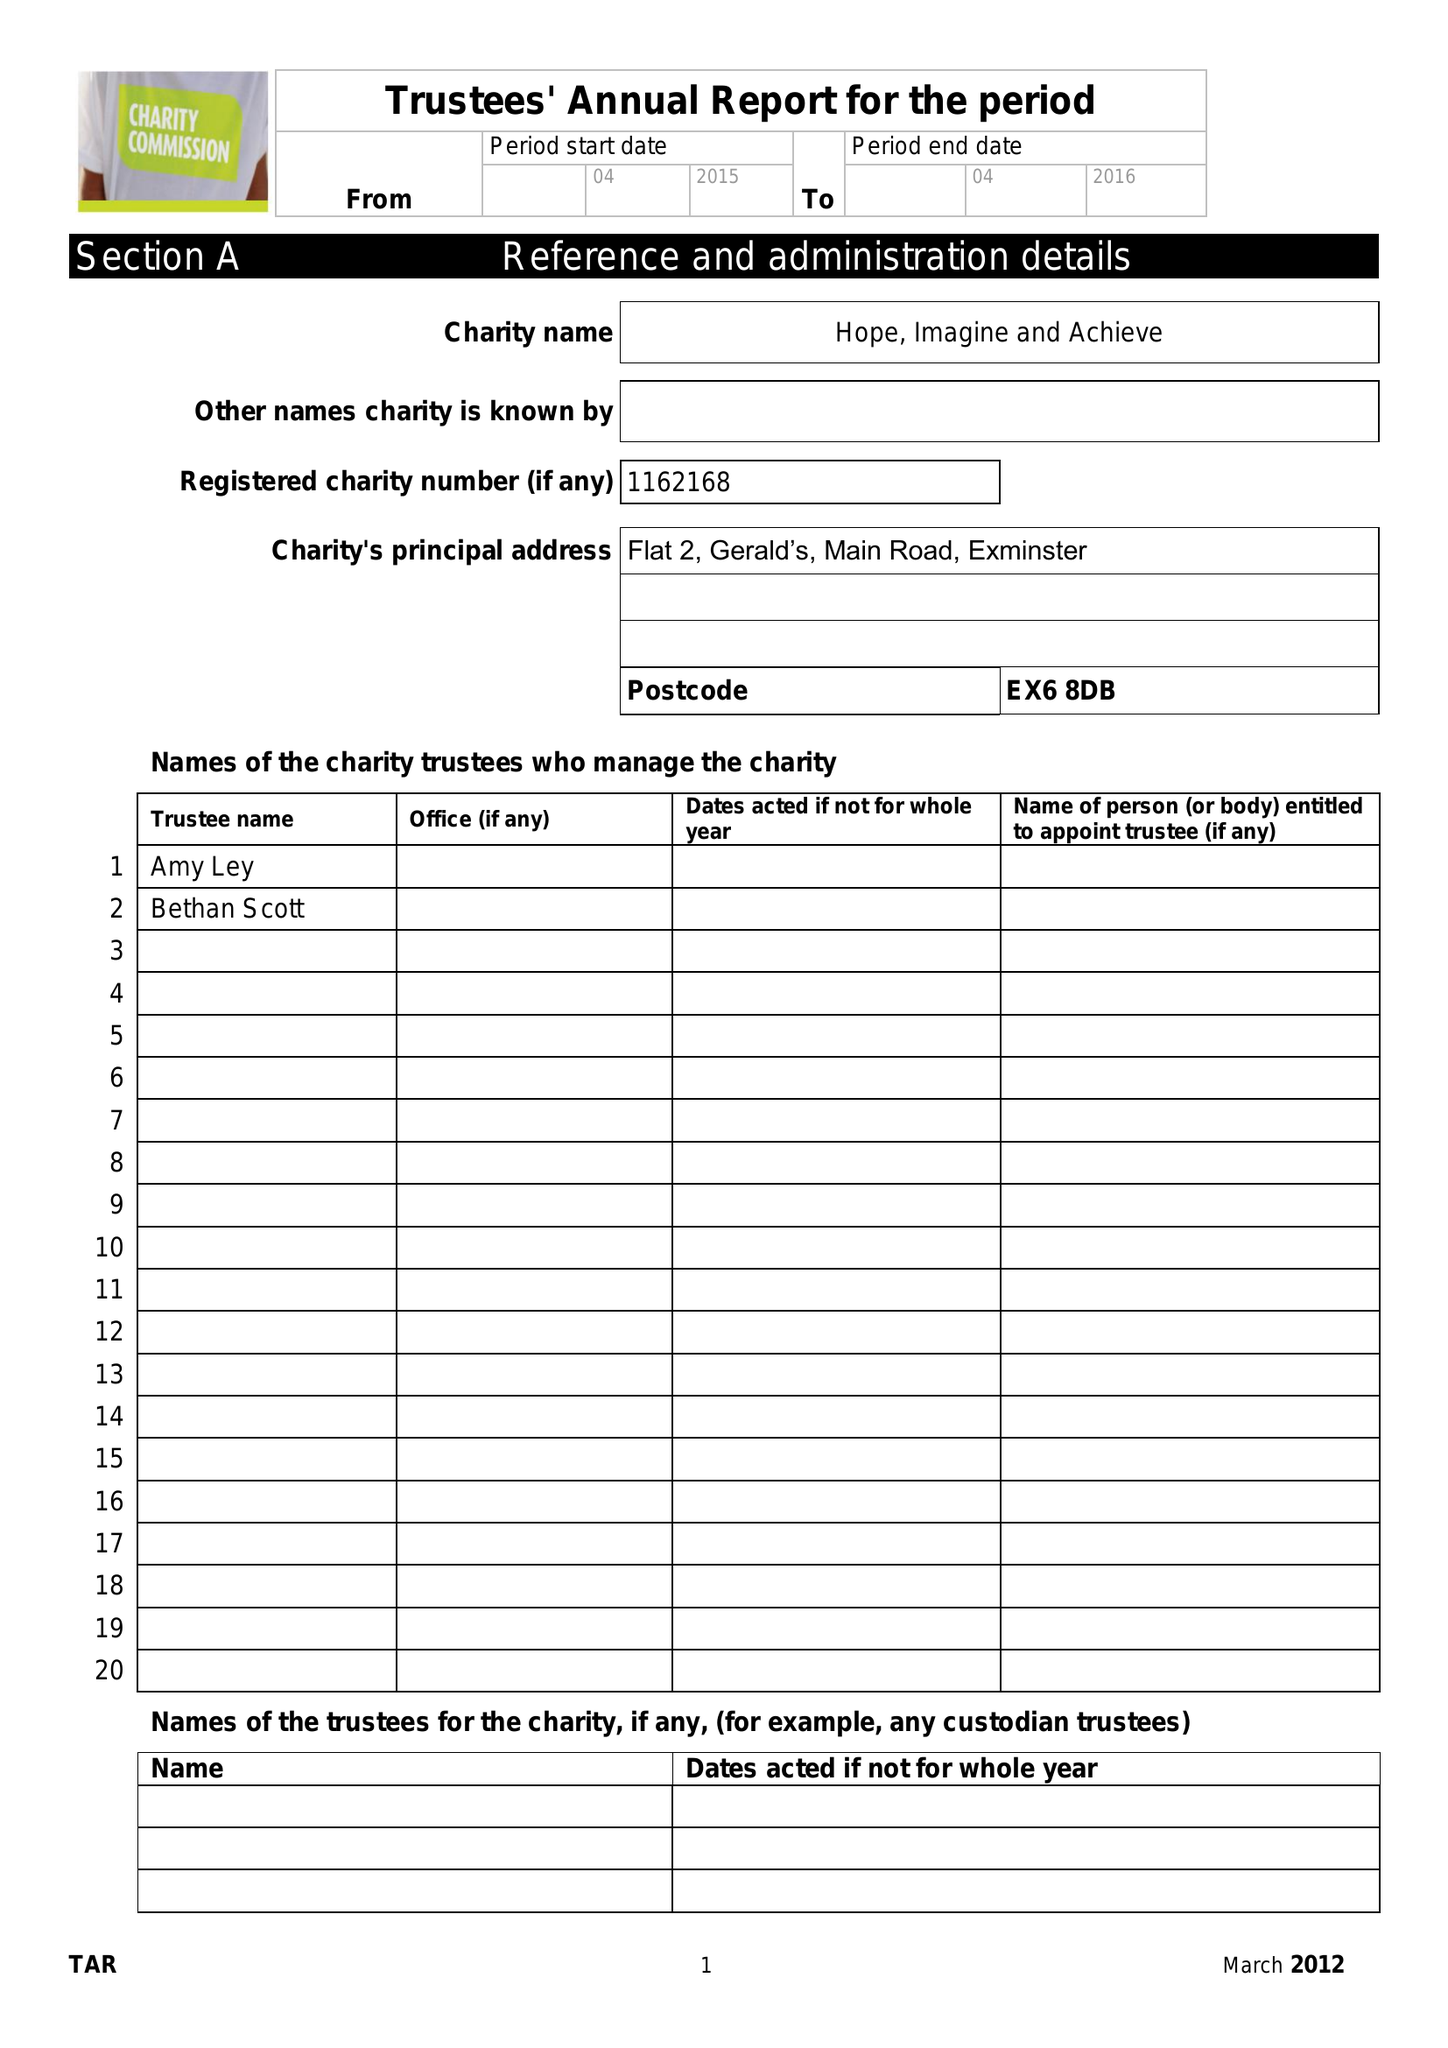What is the value for the income_annually_in_british_pounds?
Answer the question using a single word or phrase. None 